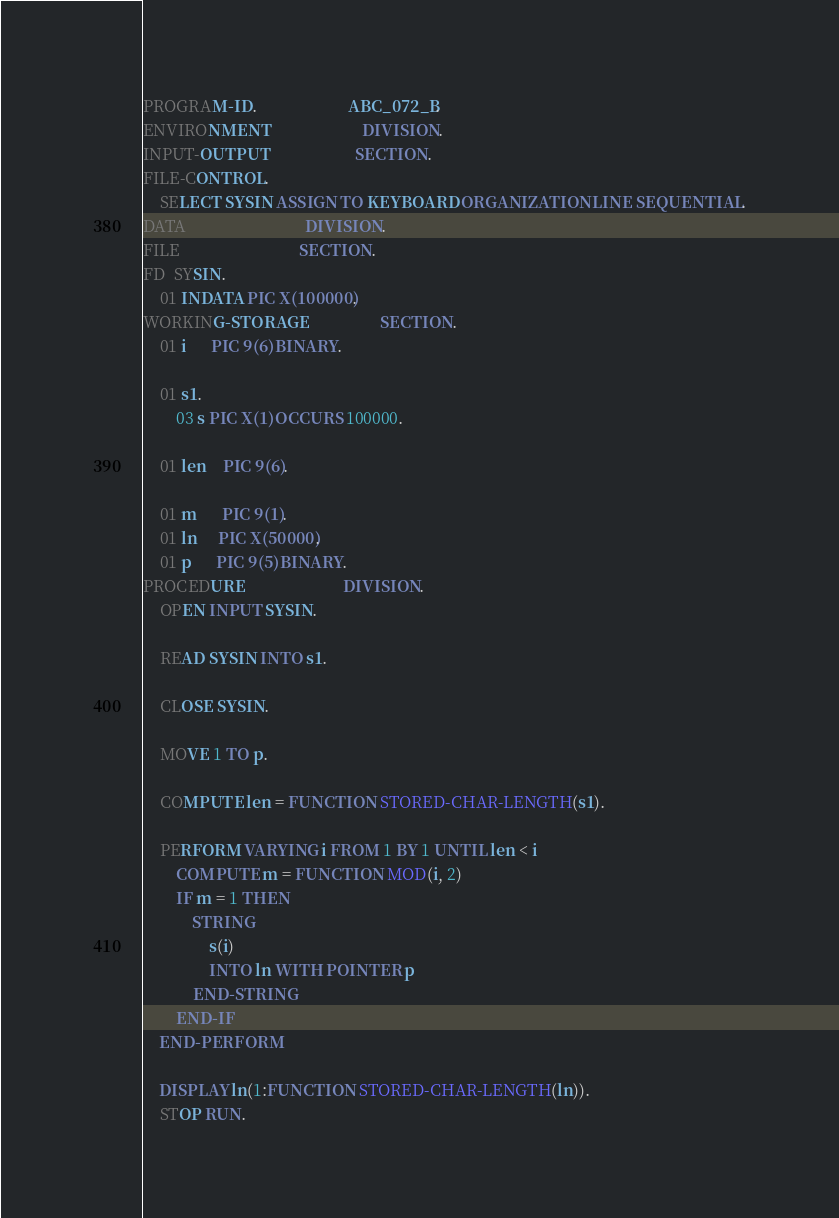<code> <loc_0><loc_0><loc_500><loc_500><_COBOL_>PROGRAM-ID.                      ABC_072_B.
ENVIRONMENT                      DIVISION.
INPUT-OUTPUT                     SECTION.
FILE-CONTROL.
    SELECT SYSIN ASSIGN TO KEYBOARD ORGANIZATION LINE SEQUENTIAL.
DATA                             DIVISION.
FILE                             SECTION.
FD  SYSIN.
    01 INDATA PIC X(100000).
WORKING-STORAGE                  SECTION.
    01 i      PIC 9(6) BINARY.

    01 s1.
        03 s PIC X(1) OCCURS 100000.

    01 len    PIC 9(6).

    01 m      PIC 9(1).
    01 ln     PIC X(50000).
    01 p      PIC 9(5) BINARY.
PROCEDURE                        DIVISION.
    OPEN INPUT SYSIN.

    READ SYSIN INTO s1.

    CLOSE SYSIN.

    MOVE 1 TO p.

    COMPUTE len = FUNCTION STORED-CHAR-LENGTH(s1).

    PERFORM VARYING i FROM 1 BY 1 UNTIL len < i
        COMPUTE m = FUNCTION MOD(i, 2)
        IF m = 1 THEN
            STRING
                s(i)
                INTO ln WITH POINTER p
            END-STRING
        END-IF
    END-PERFORM

    DISPLAY ln(1:FUNCTION STORED-CHAR-LENGTH(ln)).
    STOP RUN.
</code> 